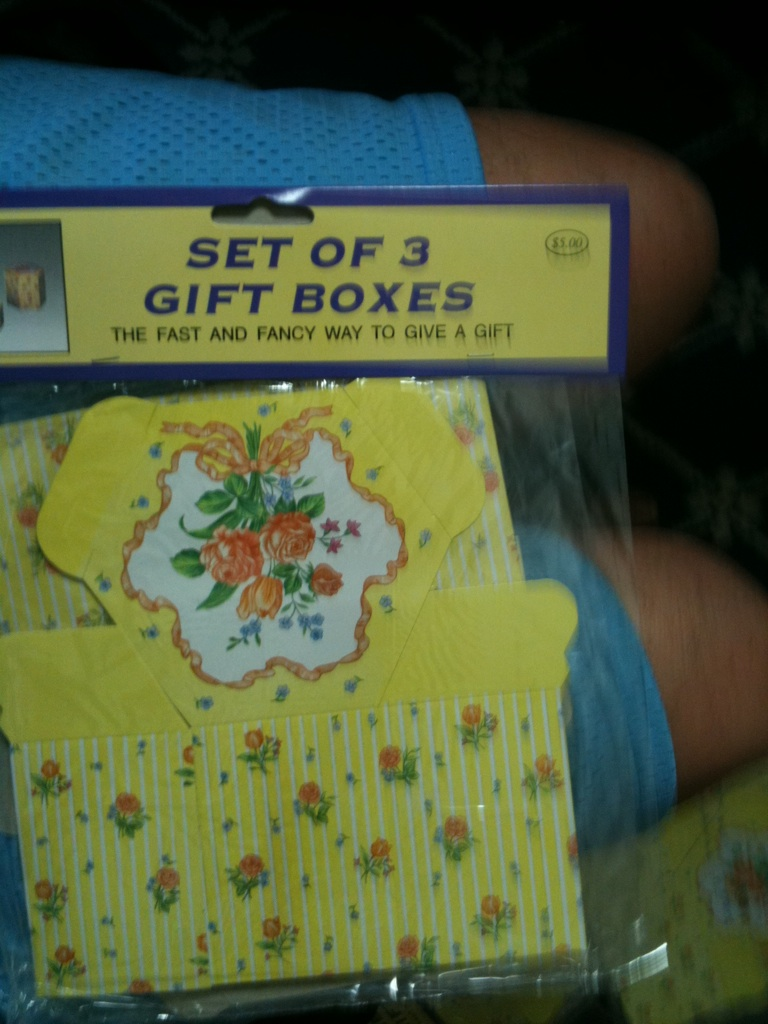What is this item? The item in the image is a set of three coordinated gift boxes, designed for an appealing and convenient gift presentation. Each box is beautifully decorated with a floral pattern and vibrant colors, making them perfect for special occasions. 